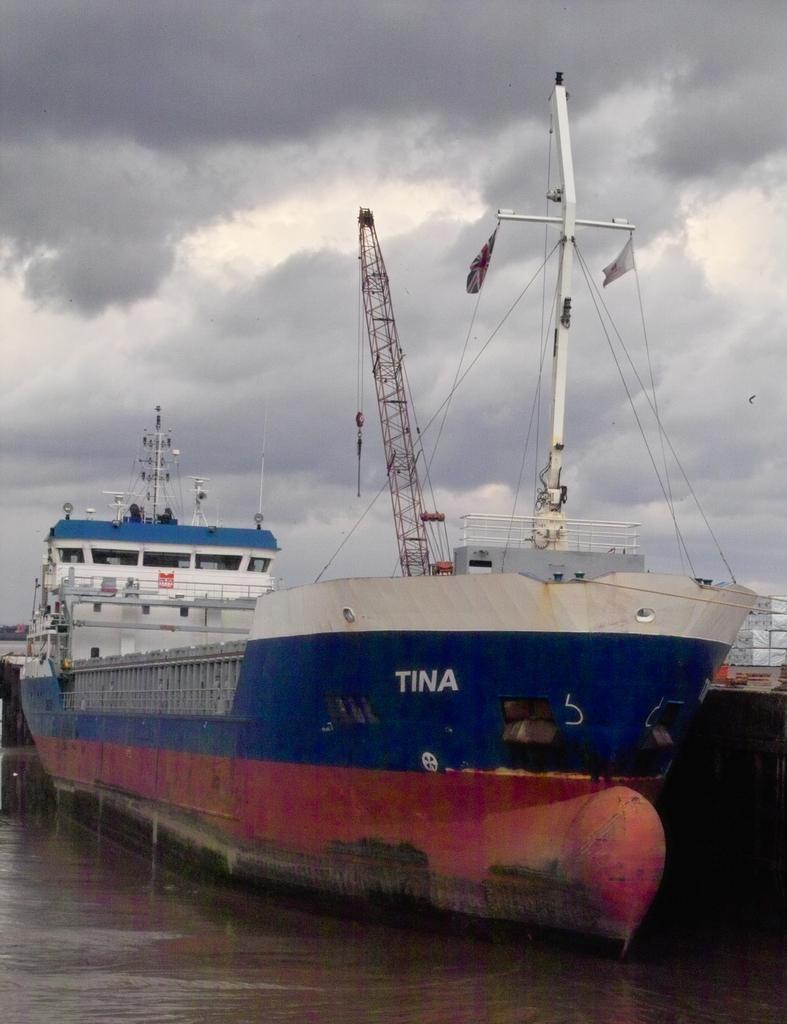What is the main subject of the image? The main subject of the image is a ship. What colors can be seen on the ship? The ship has blue, red, and white colors. Where is the ship located in the image? The ship is in the water. What is visible at the top of the image? The sky is visible at the top of the image. What is the condition of the sky in the image? The sky appears to be cloudy. What type of zinc can be seen on the ship in the image? There is no zinc present on the ship in the image. How does the bell on the ship ring in the image? There is no bell present on the ship in the image. 